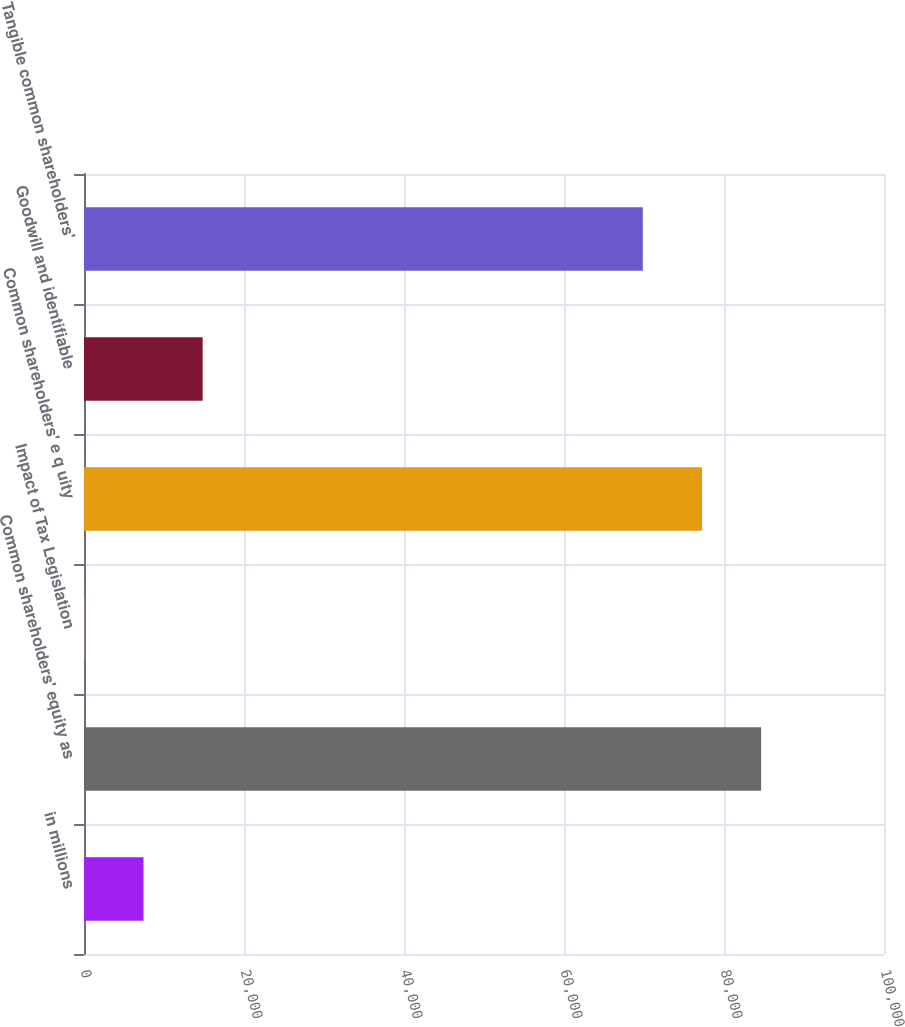Convert chart. <chart><loc_0><loc_0><loc_500><loc_500><bar_chart><fcel>in millions<fcel>Common shareholders' equity as<fcel>Impact of Tax Legislation<fcel>Common shareholders' e q uity<fcel>Goodwill and identifiable<fcel>Tangible common shareholders'<nl><fcel>7436.3<fcel>84641.6<fcel>42<fcel>77247.3<fcel>14830.6<fcel>69853<nl></chart> 